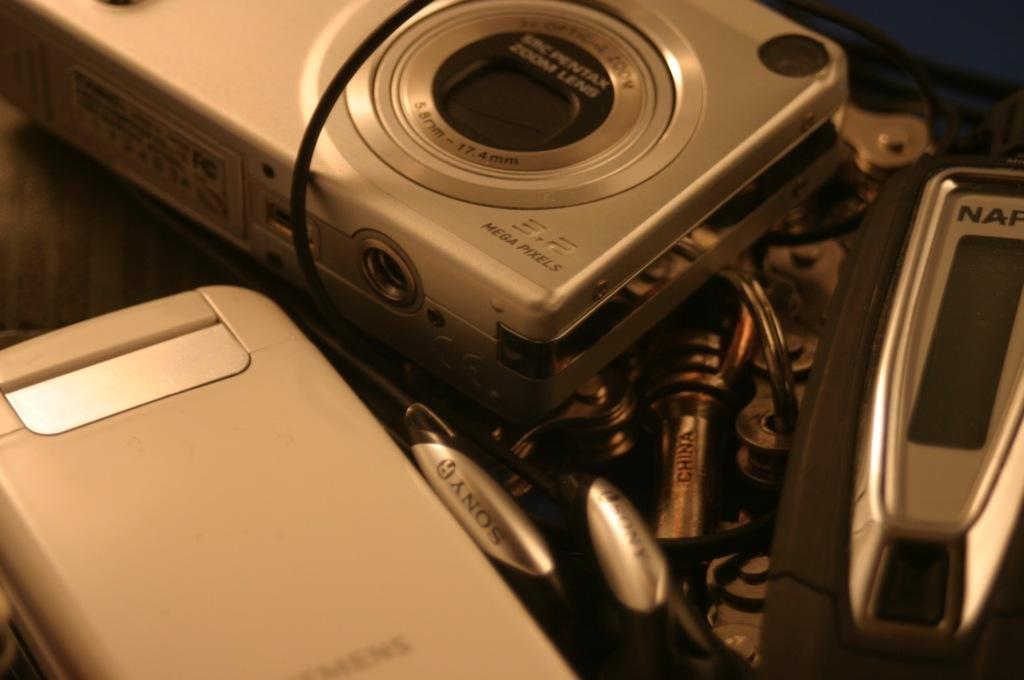What is the main object in the image? There is a camera in the image. What is the color of the camera? The camera is ash in color. What part of the camera is used for capturing images? The camera has a lens. What other electronic items can be seen in the image? There are electronic items beside the camera in the image. How many frogs are sitting on top of the camera in the image? There are no frogs present in the image. What type of paper is used to wrap the camera in the image? There is no paper used to wrap the camera in the image. 